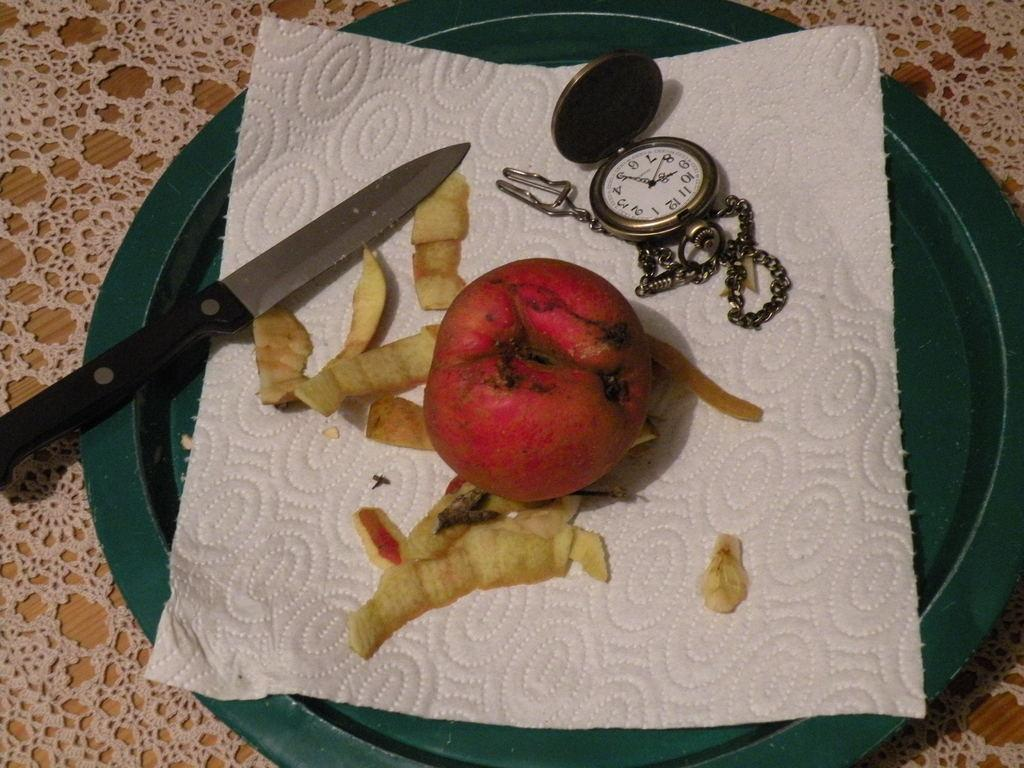What is located at the bottom of the image? There is a table at the bottom of the image. What is on the table? On the table, there is a plate. What is on the plate? In the plate, there is a fruit. Are there any utensils or objects on the plate? Yes, there is a knife on the plate. Are there any additional items on the plate? Yes, there is a clock and a keychain on the plate. How many children are playing with the cactus in the image? There are no children or cactus present in the image. What type of drop can be seen falling from the keychain in the image? There is no drop falling from the keychain in the image. 